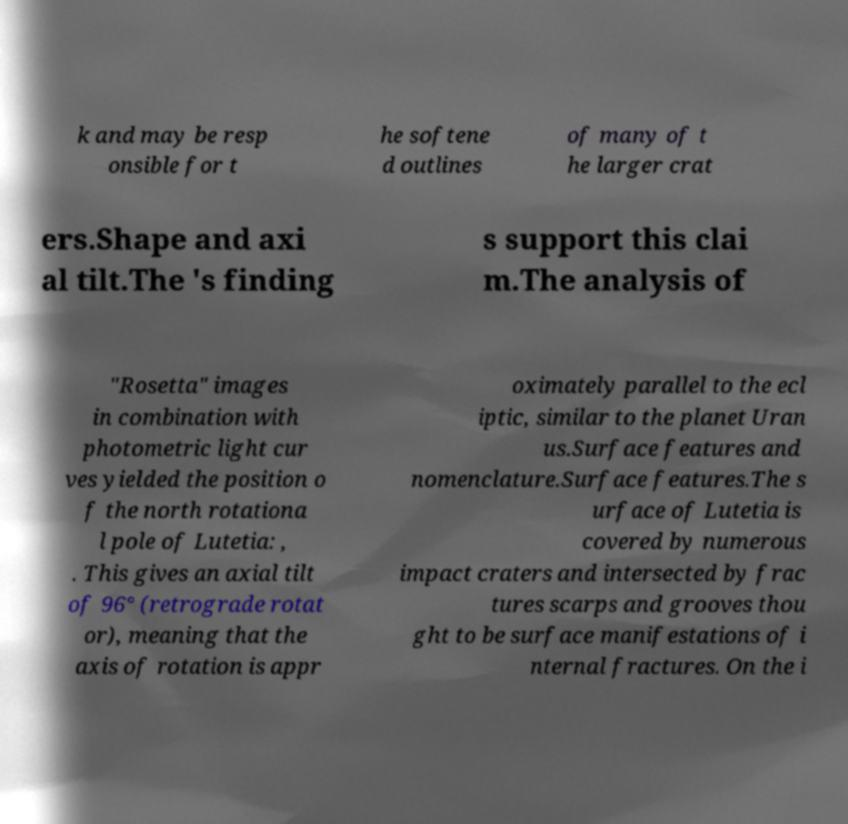Please read and relay the text visible in this image. What does it say? k and may be resp onsible for t he softene d outlines of many of t he larger crat ers.Shape and axi al tilt.The 's finding s support this clai m.The analysis of "Rosetta" images in combination with photometric light cur ves yielded the position o f the north rotationa l pole of Lutetia: , . This gives an axial tilt of 96° (retrograde rotat or), meaning that the axis of rotation is appr oximately parallel to the ecl iptic, similar to the planet Uran us.Surface features and nomenclature.Surface features.The s urface of Lutetia is covered by numerous impact craters and intersected by frac tures scarps and grooves thou ght to be surface manifestations of i nternal fractures. On the i 